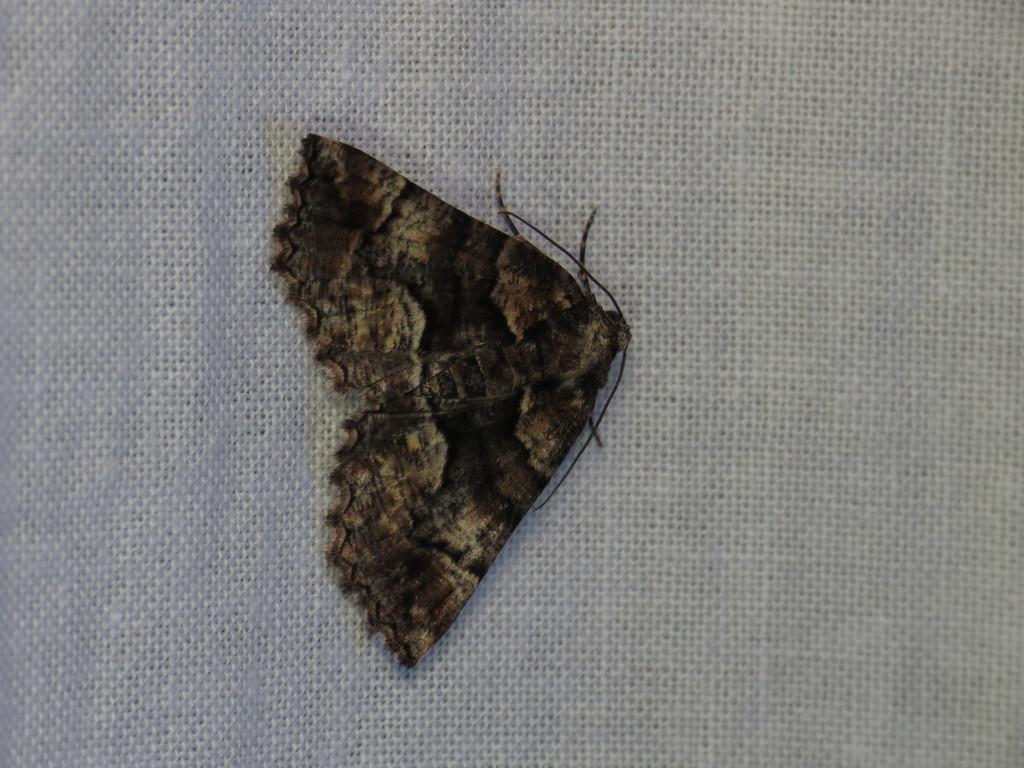What type of creature is present in the image? There is an insect in the image. What does the insect resemble? The insect resembles a butterfly. What color is the insect? The insect is black in color. What is the color of the background in the image? The background of the image is white. What type of design can be seen on the slope in the image? There is no slope or design present in the image; it features an insect against a white background. 